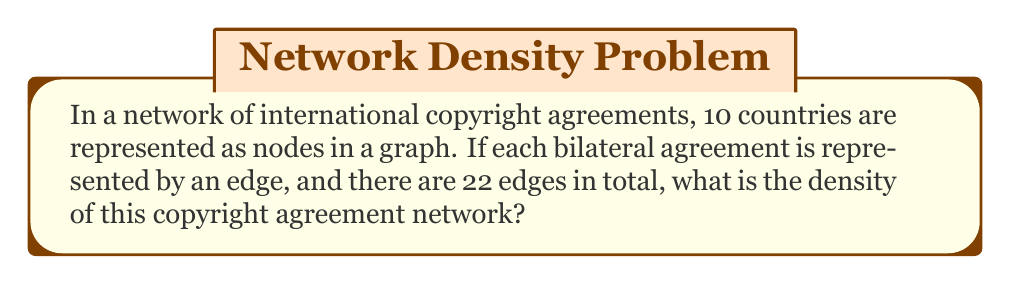Teach me how to tackle this problem. To solve this problem, we'll follow these steps:

1. Understand the concept of graph density:
   Graph density is a measure of how many edges are in a graph compared to the maximum possible number of edges. For an undirected graph, it's calculated as:

   $$ D = \frac{2|E|}{|V|(|V|-1)} $$

   Where $|E|$ is the number of edges and $|V|$ is the number of vertices (nodes).

2. Identify the given information:
   - Number of countries (nodes): $|V| = 10$
   - Number of bilateral agreements (edges): $|E| = 22$

3. Calculate the maximum possible number of edges:
   For an undirected graph with 10 nodes, the maximum number of edges is:
   $$ \frac{10 \cdot (10-1)}{2} = \frac{10 \cdot 9}{2} = 45 $$

4. Apply the density formula:
   $$ D = \frac{2 \cdot 22}{10 \cdot (10-1)} = \frac{44}{90} $$

5. Simplify the fraction:
   $$ D = \frac{22}{45} \approx 0.4889 $$

This density value indicates that about 48.89% of all possible bilateral copyright agreements are in place in this network.
Answer: $\frac{22}{45}$ 